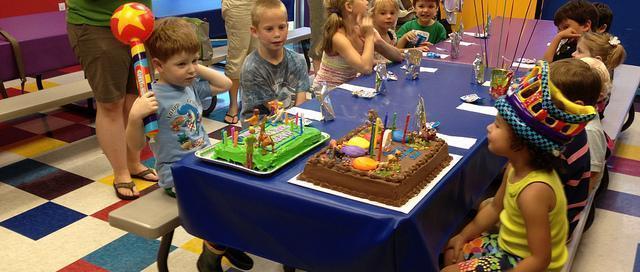What relationship might these two children with the birthday cakes likely have?
Indicate the correct response and explain using: 'Answer: answer
Rationale: rationale.'
Options: Random strangers, enemies, they're twins, none. Answer: they're twins.
Rationale: They might just have birthdays on the same day. Where is this party taking place?
Choose the correct response, then elucidate: 'Answer: answer
Rationale: rationale.'
Options: Formal restaurant, home, kid's restaurant, club. Answer: kid's restaurant.
Rationale: The colorful carpet and the long table suggests that it is a restaurant which does kid's birthday parties. 